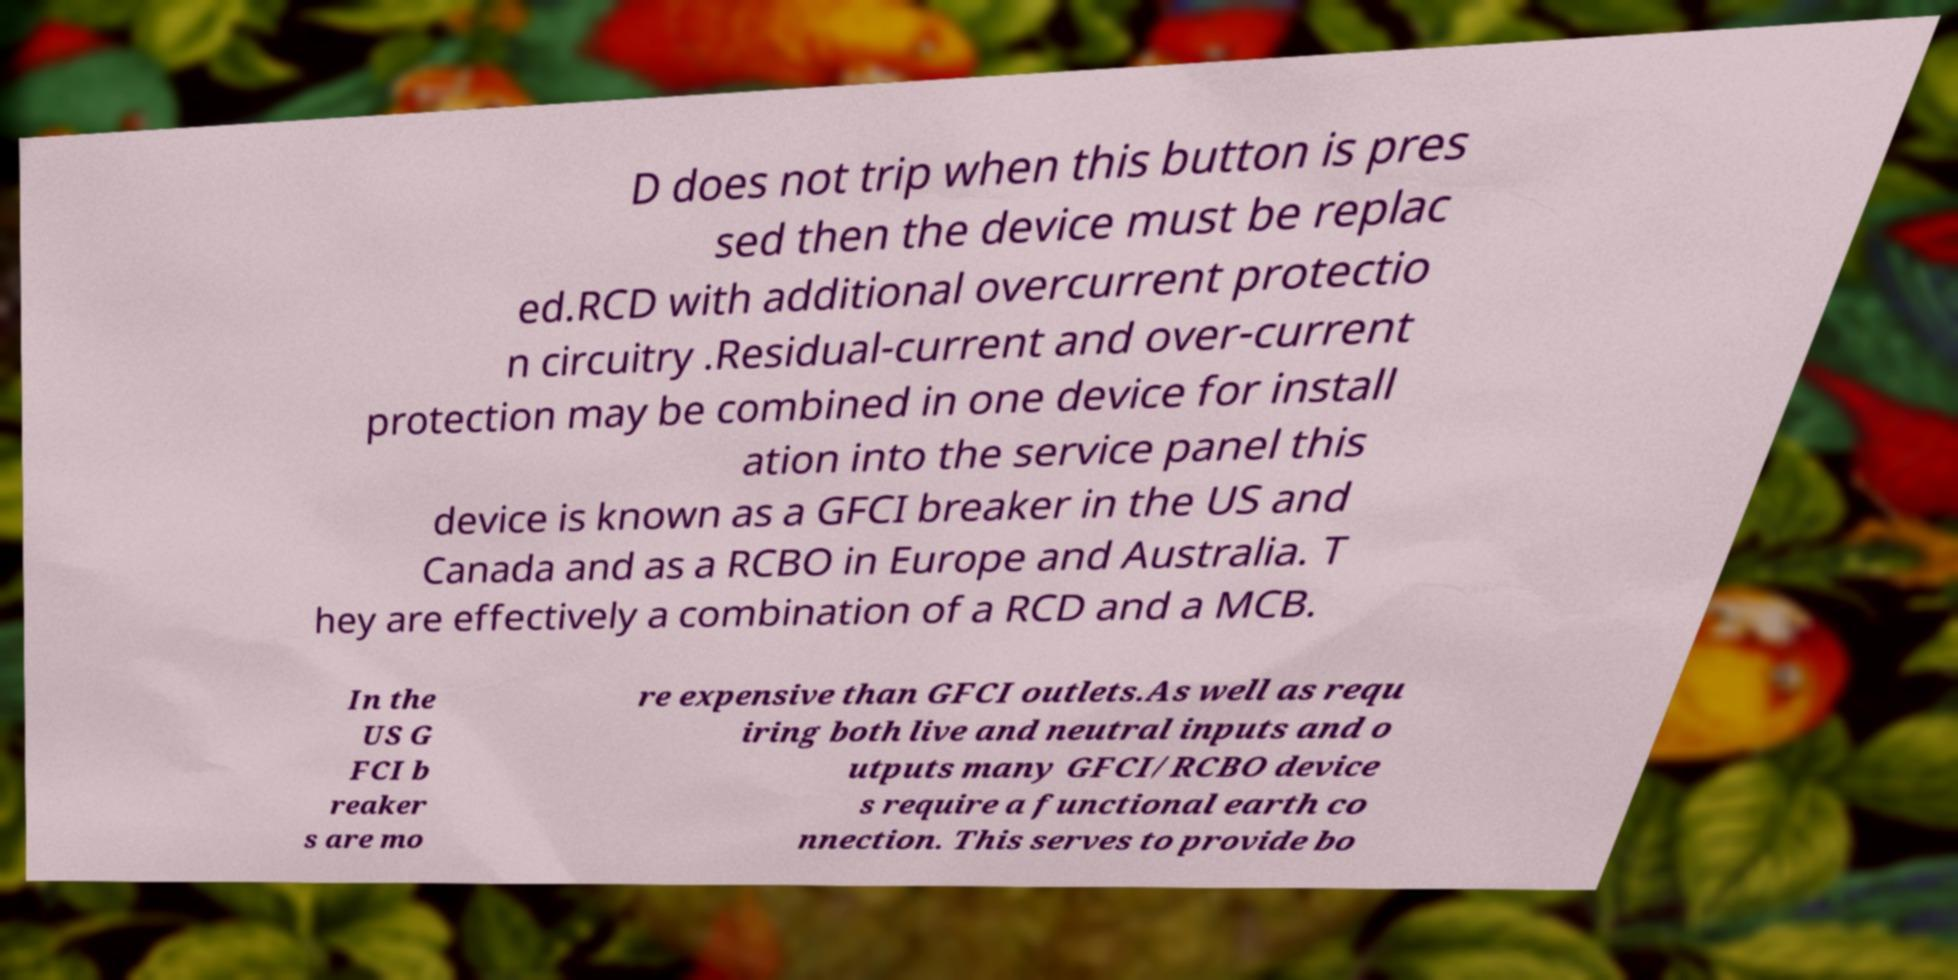Please read and relay the text visible in this image. What does it say? D does not trip when this button is pres sed then the device must be replac ed.RCD with additional overcurrent protectio n circuitry .Residual-current and over-current protection may be combined in one device for install ation into the service panel this device is known as a GFCI breaker in the US and Canada and as a RCBO in Europe and Australia. T hey are effectively a combination of a RCD and a MCB. In the US G FCI b reaker s are mo re expensive than GFCI outlets.As well as requ iring both live and neutral inputs and o utputs many GFCI/RCBO device s require a functional earth co nnection. This serves to provide bo 